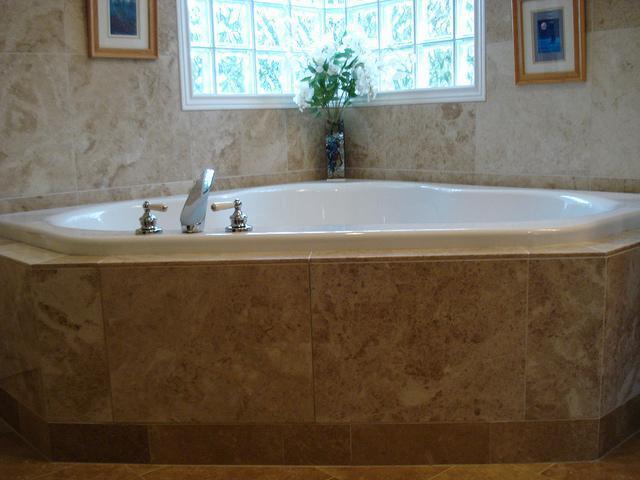How many pictures are on the wall?
Give a very brief answer. 2. 